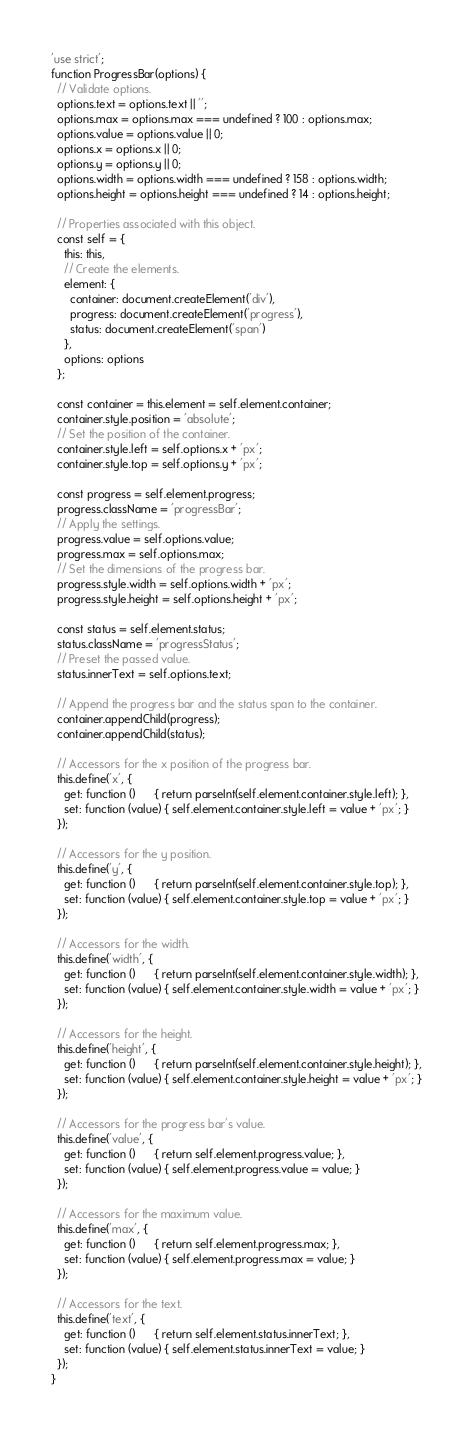Convert code to text. <code><loc_0><loc_0><loc_500><loc_500><_JavaScript_>'use strict';
function ProgressBar(options) {
  // Validate options.
  options.text = options.text || '';
  options.max = options.max === undefined ? 100 : options.max;
  options.value = options.value || 0;
  options.x = options.x || 0;
  options.y = options.y || 0;
  options.width = options.width === undefined ? 158 : options.width;
  options.height = options.height === undefined ? 14 : options.height;

  // Properties associated with this object.
  const self = {
    this: this,
    // Create the elements.
    element: {
      container: document.createElement('div'),
      progress: document.createElement('progress'),
      status: document.createElement('span')
    },
    options: options
  };

  const container = this.element = self.element.container;
  container.style.position = 'absolute';
  // Set the position of the container.
  container.style.left = self.options.x + 'px';
  container.style.top = self.options.y + 'px';

  const progress = self.element.progress;
  progress.className = 'progressBar';
  // Apply the settings.
  progress.value = self.options.value;
  progress.max = self.options.max;
  // Set the dimensions of the progress bar.
  progress.style.width = self.options.width + 'px';
  progress.style.height = self.options.height + 'px';

  const status = self.element.status;
  status.className = 'progressStatus';
  // Preset the passed value.
  status.innerText = self.options.text;

  // Append the progress bar and the status span to the container.
  container.appendChild(progress);
  container.appendChild(status);

  // Accessors for the x position of the progress bar.
  this.define('x', {
    get: function ()      { return parseInt(self.element.container.style.left); },
    set: function (value) { self.element.container.style.left = value + 'px'; }
  });

  // Accessors for the y position.
  this.define('y', {
    get: function ()      { return parseInt(self.element.container.style.top); },
    set: function (value) { self.element.container.style.top = value + 'px'; }
  });

  // Accessors for the width.
  this.define('width', {
    get: function ()      { return parseInt(self.element.container.style.width); },
    set: function (value) { self.element.container.style.width = value + 'px'; }
  });

  // Accessors for the height.
  this.define('height', {
    get: function ()      { return parseInt(self.element.container.style.height); },
    set: function (value) { self.element.container.style.height = value + 'px'; }
  });

  // Accessors for the progress bar's value.
  this.define('value', {
    get: function ()      { return self.element.progress.value; },
    set: function (value) { self.element.progress.value = value; }
  });

  // Accessors for the maximum value.
  this.define('max', {
    get: function ()      { return self.element.progress.max; },
    set: function (value) { self.element.progress.max = value; }
  });

  // Accessors for the text.
  this.define('text', {
    get: function ()      { return self.element.status.innerText; },
    set: function (value) { self.element.status.innerText = value; }
  });
}
</code> 